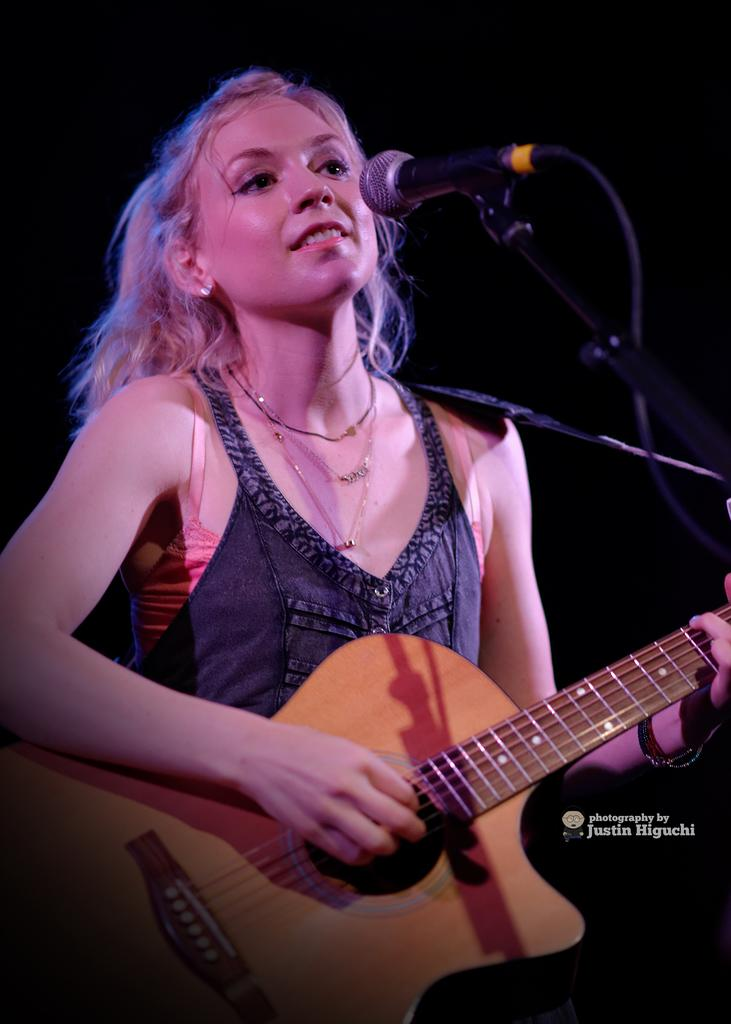What is the woman in the image holding? The woman is holding a guitar. What is the woman's facial expression in the image? The woman is smiling. What object is in front of the woman? There is a microphone in front of the woman. What type of poison can be seen in the image? There is no poison present in the image. Is the woman at a zoo in the image? There is no indication of a zoo or any animals in the image. 